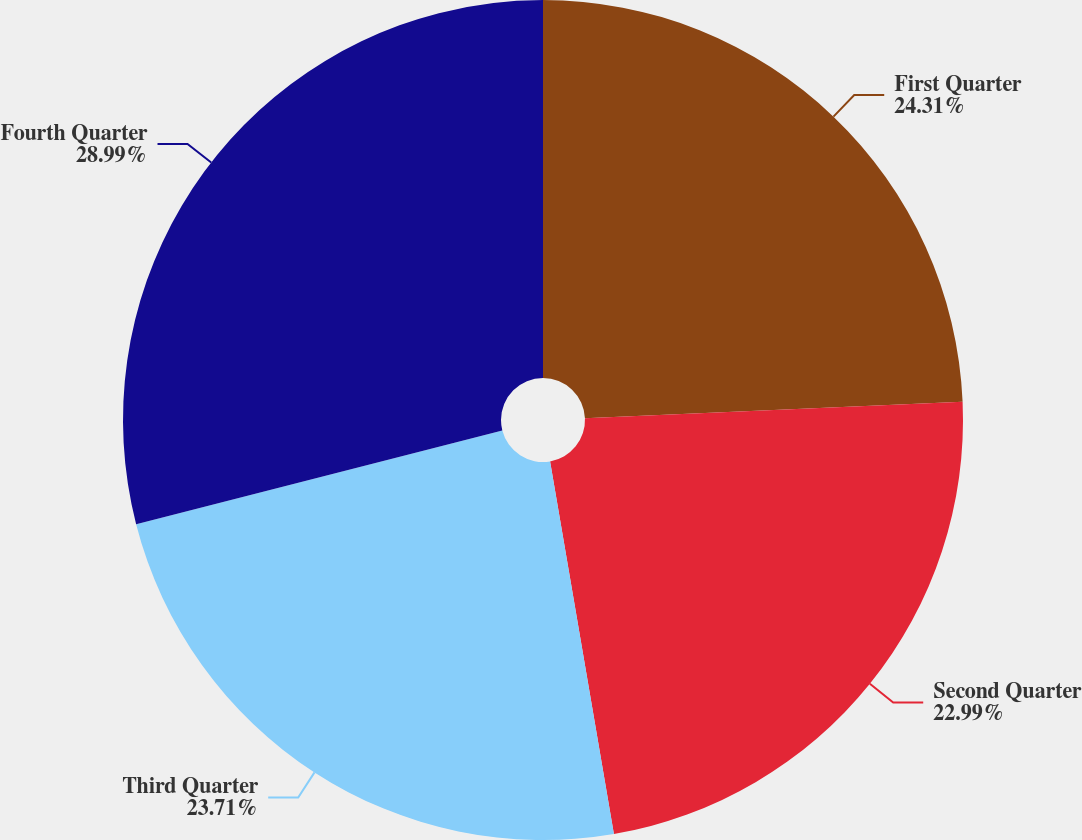Convert chart to OTSL. <chart><loc_0><loc_0><loc_500><loc_500><pie_chart><fcel>First Quarter<fcel>Second Quarter<fcel>Third Quarter<fcel>Fourth Quarter<nl><fcel>24.31%<fcel>22.99%<fcel>23.71%<fcel>28.99%<nl></chart> 